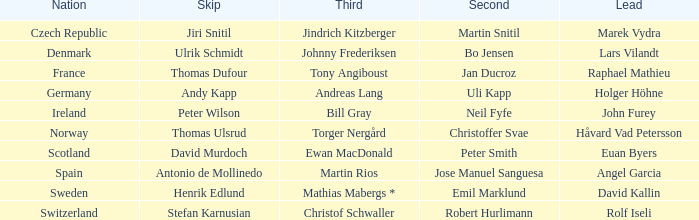When did france achieve the runner-up position? Jan Ducroz. 